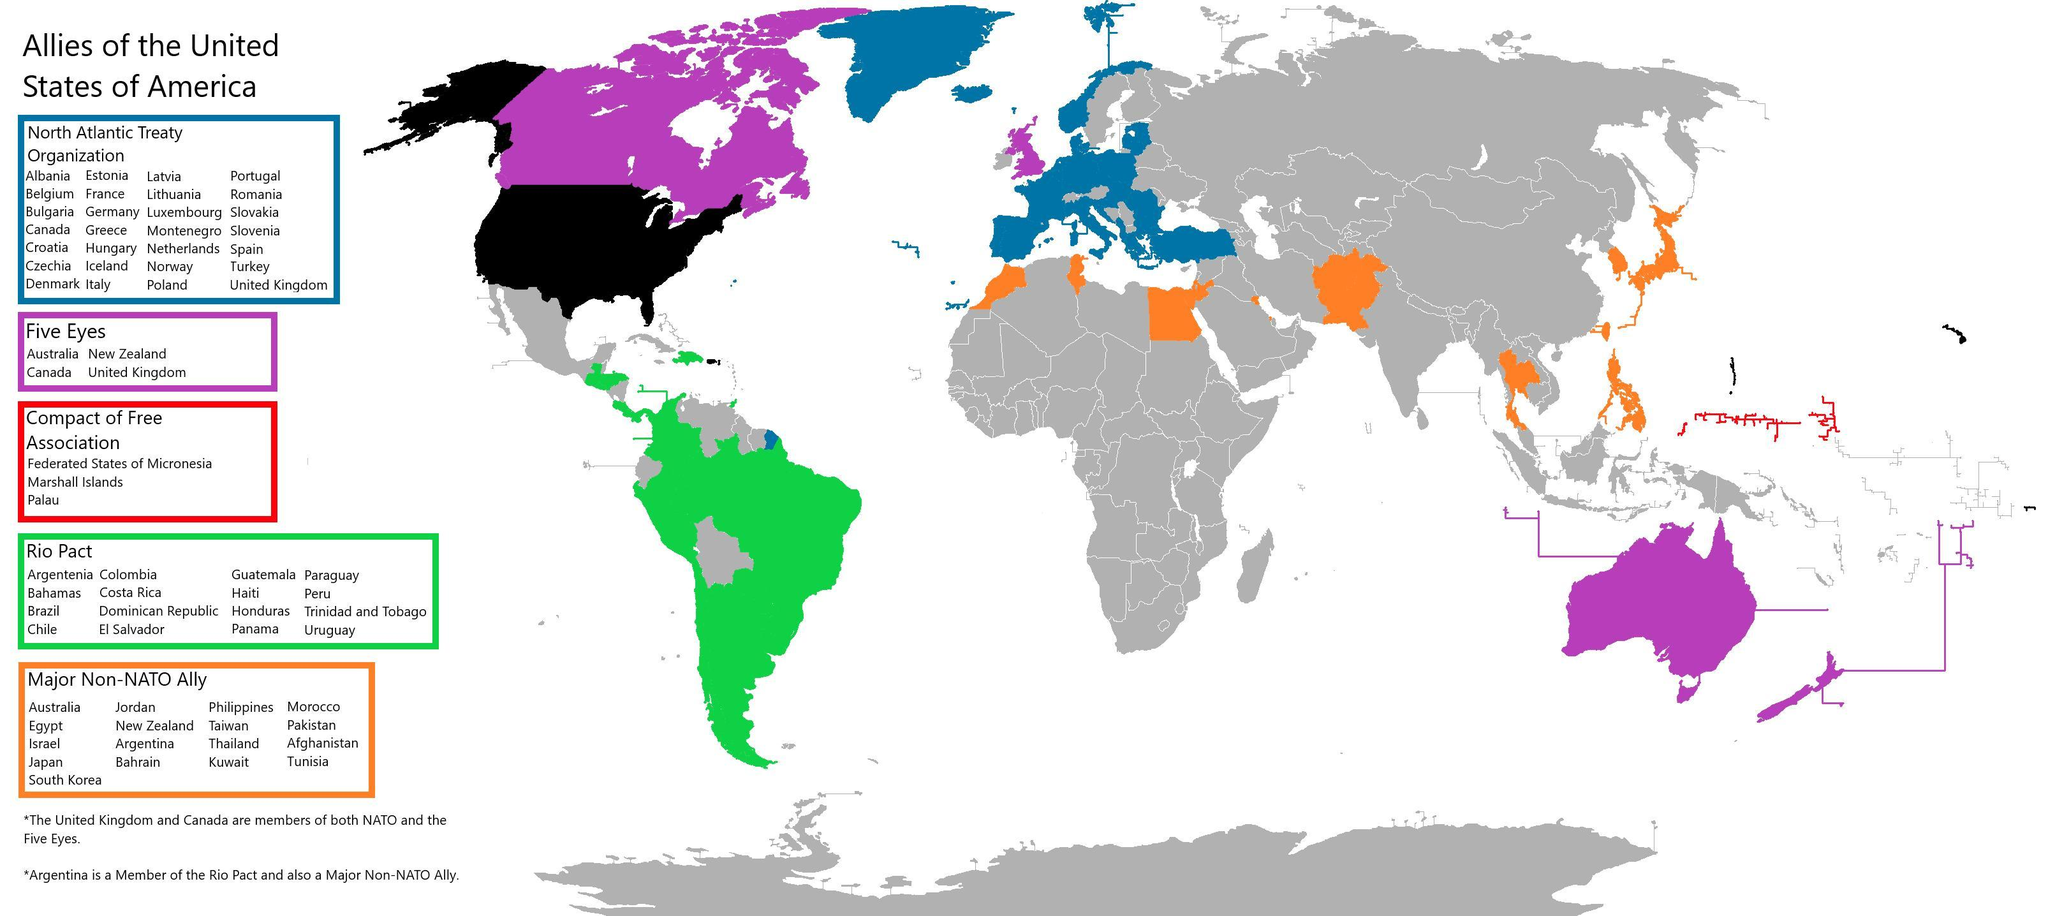The country Kuwait is part of which Ally?
Answer the question with a short phrase. major Non-Nato Ally How many countries have signed Compact of Free Association? 3 The country Romania is part of which Ally? North Atlantic Treaty Organization How many countries have signed RIO PACT? 16 How many countries have signed the major Non-NATO Ally? 17 The country Uruguay is part of which Ally? Rio Pact How many Allies are there for United States? 5 How many countries have signed Five Eyes? 4 How many countries have signed the NATO Ally? 28 Which is the color used to map Rio Pact- red, green, yellow, purple? green 